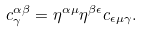Convert formula to latex. <formula><loc_0><loc_0><loc_500><loc_500>c _ { \gamma } ^ { \alpha \beta } = \eta ^ { \alpha \mu } \eta ^ { \beta \epsilon } c _ { \epsilon \mu \gamma } .</formula> 